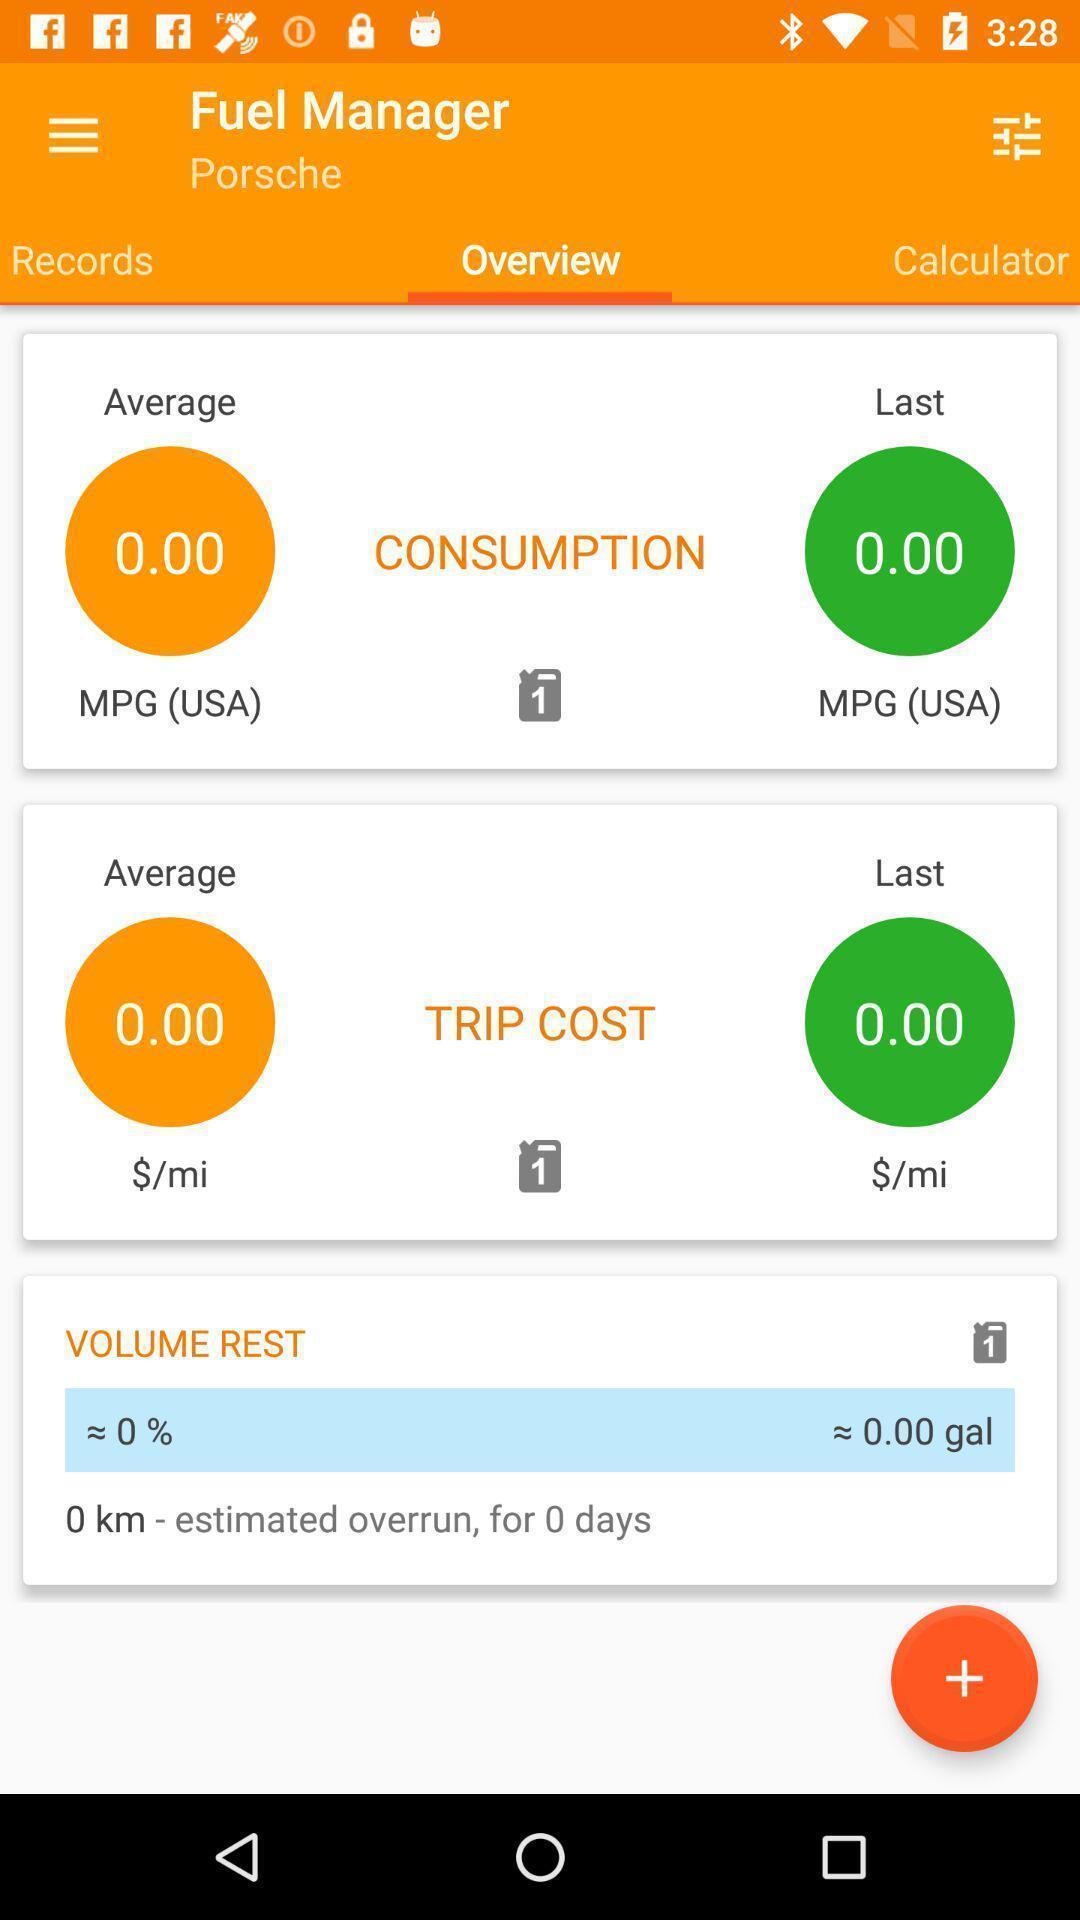Summarize the main components in this picture. Screen showing overview of a fuel management. 